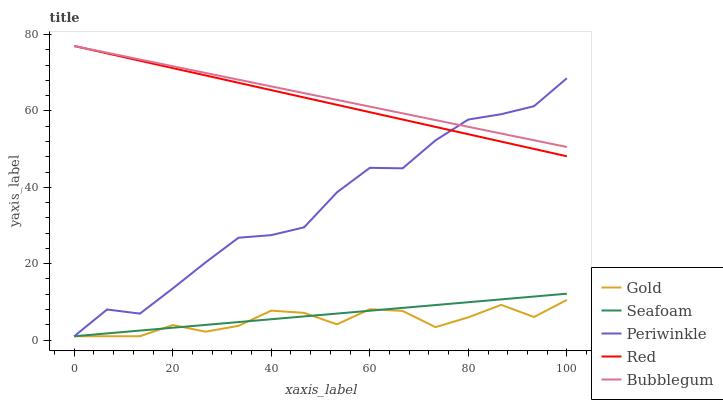Does Gold have the minimum area under the curve?
Answer yes or no. Yes. Does Bubblegum have the maximum area under the curve?
Answer yes or no. Yes. Does Periwinkle have the minimum area under the curve?
Answer yes or no. No. Does Periwinkle have the maximum area under the curve?
Answer yes or no. No. Is Seafoam the smoothest?
Answer yes or no. Yes. Is Periwinkle the roughest?
Answer yes or no. Yes. Is Bubblegum the smoothest?
Answer yes or no. No. Is Bubblegum the roughest?
Answer yes or no. No. Does Periwinkle have the lowest value?
Answer yes or no. Yes. Does Bubblegum have the lowest value?
Answer yes or no. No. Does Bubblegum have the highest value?
Answer yes or no. Yes. Does Periwinkle have the highest value?
Answer yes or no. No. Is Seafoam less than Red?
Answer yes or no. Yes. Is Bubblegum greater than Gold?
Answer yes or no. Yes. Does Red intersect Periwinkle?
Answer yes or no. Yes. Is Red less than Periwinkle?
Answer yes or no. No. Is Red greater than Periwinkle?
Answer yes or no. No. Does Seafoam intersect Red?
Answer yes or no. No. 